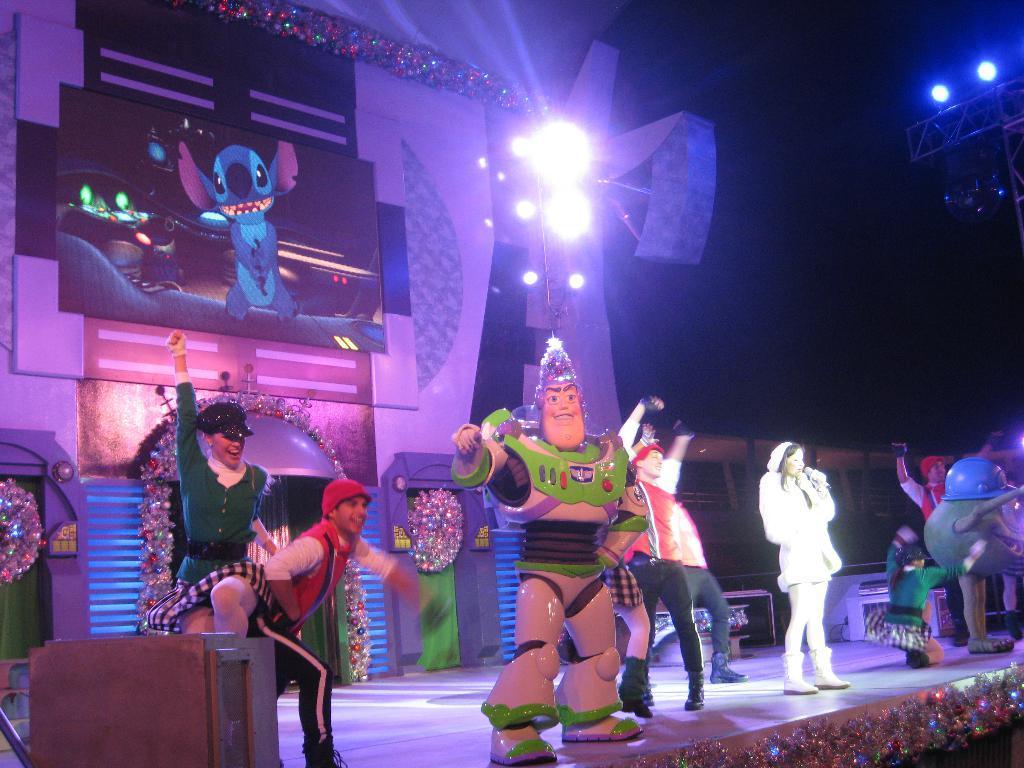In one or two sentences, can you explain what this image depicts? In this picture we can observe some people on the stage. We can observe some people who are wearing cartoon costumes on the stage. In the background we can observe lights. Behind them there is a screen in which we can observe some cartoons. The background is completely dark. 